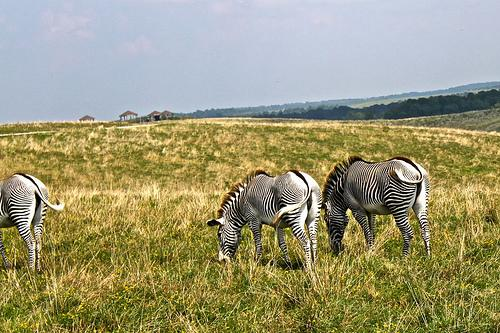Provide a brief description of the scene in the image. Three zebras are grazing on a grassy hill with trees and distant buildings in the background, under a blue cloudy sky. Describe the characteristics of the sky in the image. The sky is blue and overcast, with small cloud patches. What is the general sentiment of the image based on the description provided? The image has a calm and peaceful sentiment with zebras grazing in nature. What are the colors of the zebras in the image? The zebras are black and white. How many zebras can be seen in the image? There are three zebras in the image. 